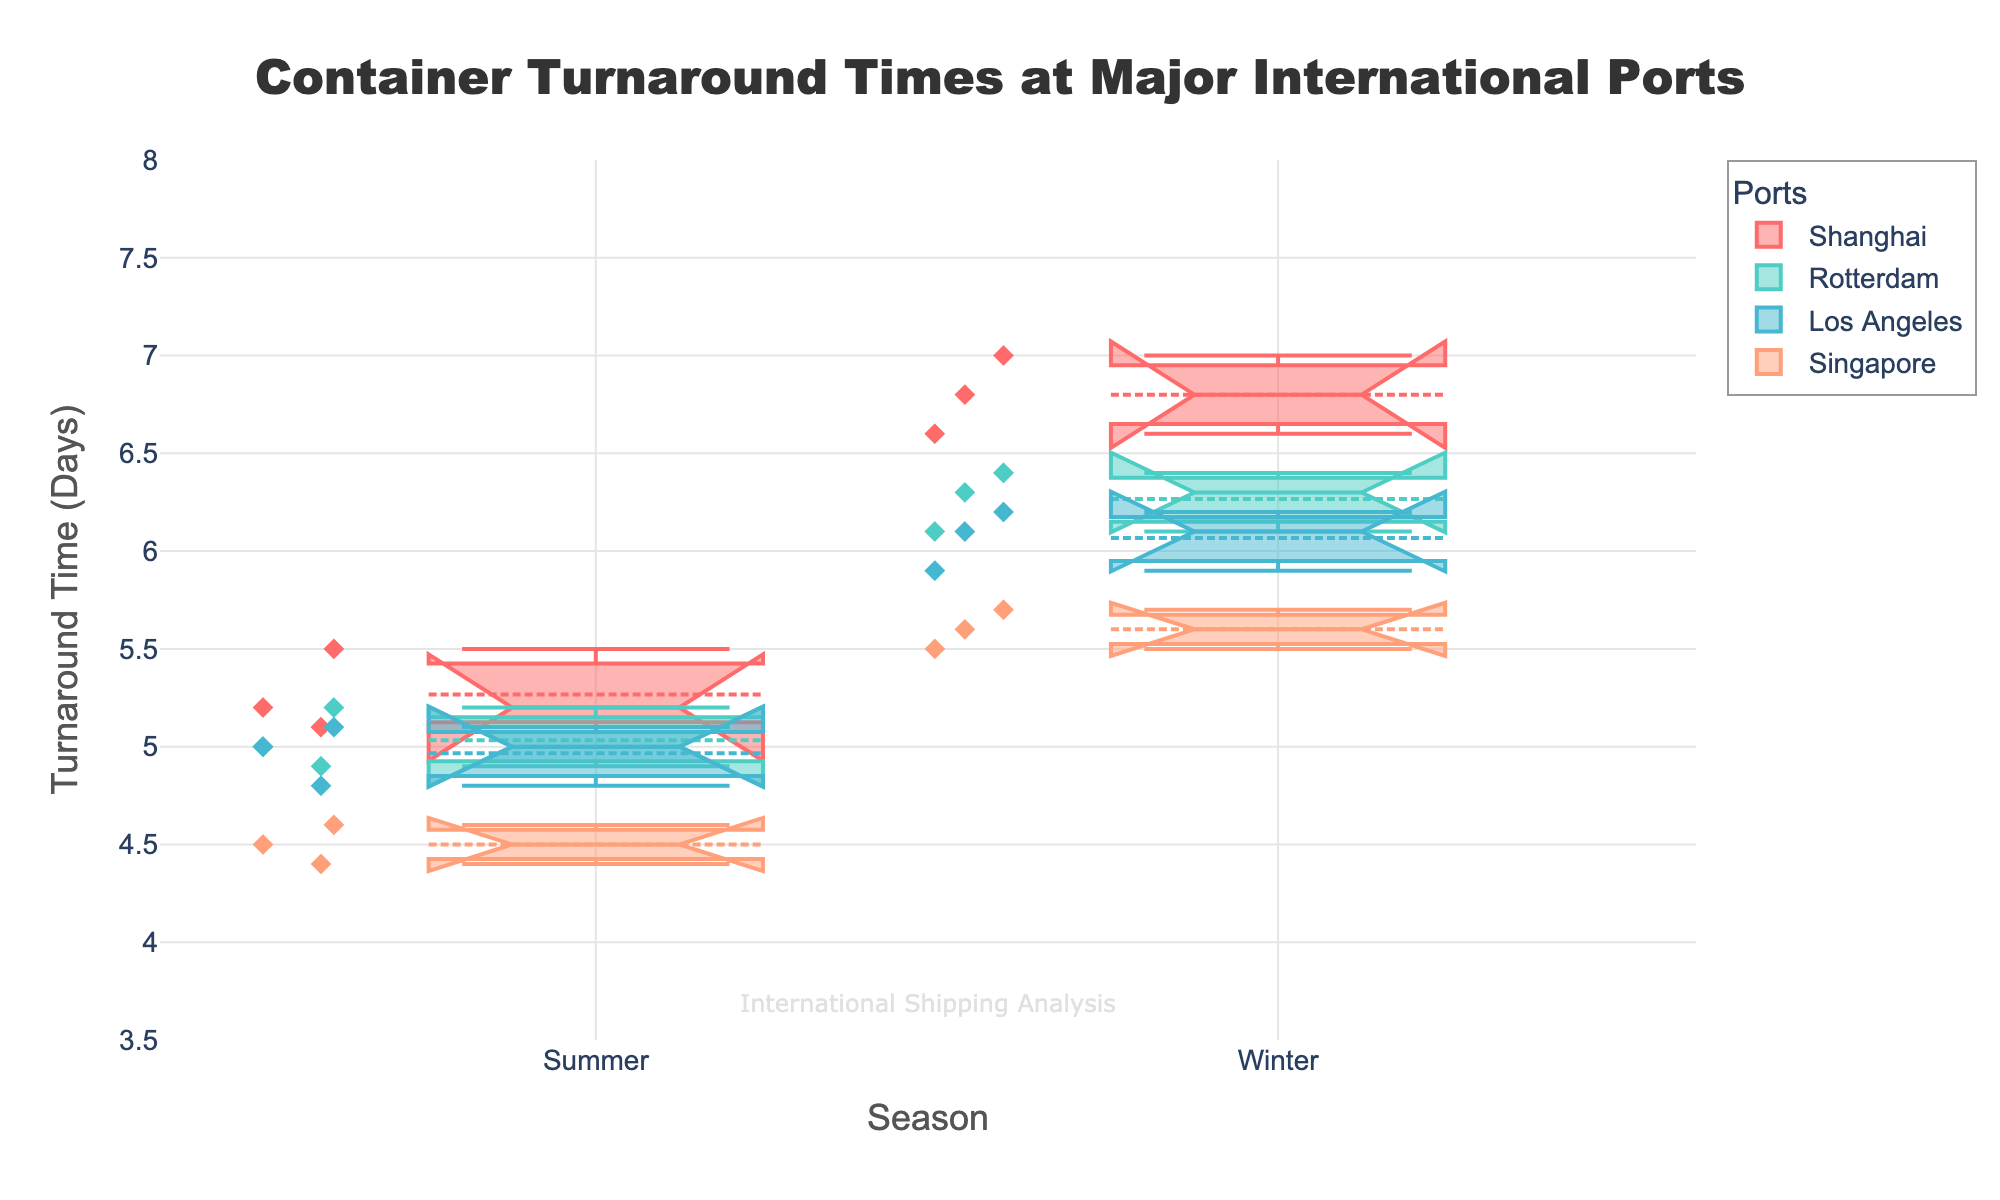Which port has the highest median turnaround time in winter? The median values are shown as lines in the center of the notched boxes. Comparing the medians of all ports for winter, Shanghai has the highest median turnaround time.
Answer: Shanghai What is the range of turnaround times in Singapore during summer? The range can be determined by identifying the minimum and maximum points for Singapore in summer. The minimum is 4.4 days and the maximum is 4.6 days. Thus, the range is 4.6 - 4.4 days.
Answer: 0.2 days Which season generally has longer turnaround times for all ports? Observing the notched boxes, the median values for all ports are higher in winter than in summer. This indicates that turnaround times are generally longer in winter for all ports.
Answer: Winter Which port shows the least variability in turnaround times during summer? Variability can be judged by the size of the notches and the spread of data points. Comparing the widths of the spread for all ports during summer, Singapore shows the least variability.
Answer: Singapore Are there any outliers in the turnaround times for Los Angeles in winter? Outliers are typically represented as individual points outside the whiskers. The box plot for Los Angeles in winter does not show any points outside the whiskers, indicating no outliers.
Answer: No How does the median turnaround time in Rotterdam for summer compare to winter? The median is represented by the line inside the box. Rotterdam's median in summer is lower than in winter. In summer, it is 5.0 days, while in winter, it is 6.3 days.
Answer: Lower in summer Which port has the broadest interquartile range (IQR) in summer? The IQR is represented by the height of the box. Comparing the boxes for all ports during summer, Shanghai has the broadest IQR.
Answer: Shanghai What is the average median turnaround time across all ports in winter? The medians are 6.8 (Shanghai), 6.3 (Rotterdam), 6.1 (Los Angeles), and 5.6 (Singapore). The average is calculated as (6.8 + 6.3 + 6.1 + 5.6) / 4.
Answer: 6.2 days 